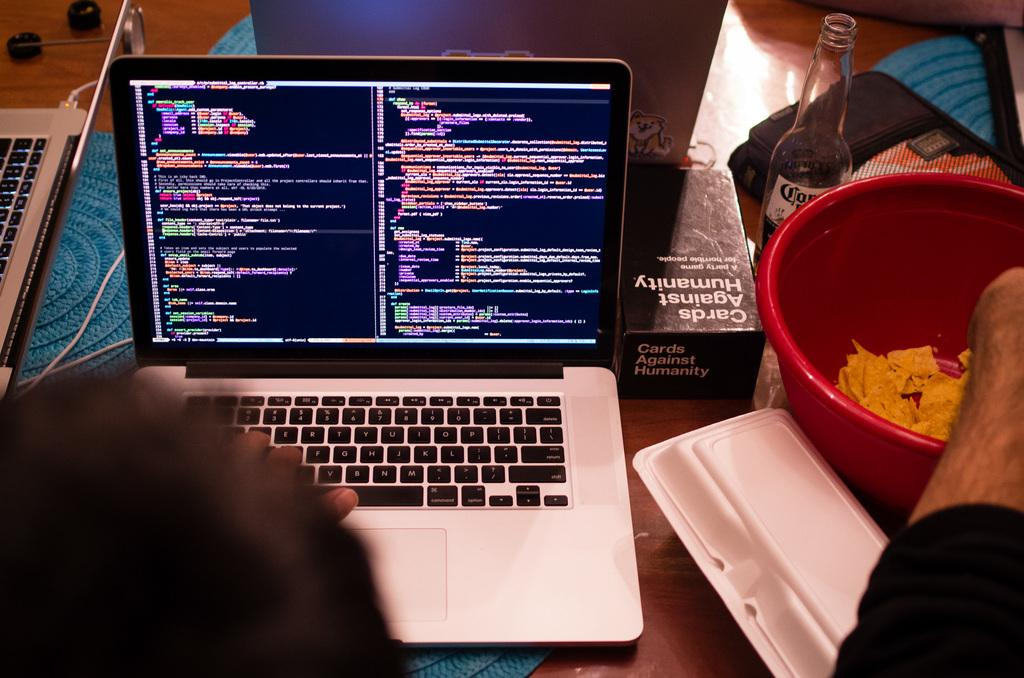What electronic device is visible in the image? There is a laptop in the image. What type of snack is in the bowl in the image? There is a bowl with chips in the image. What beverage container is present in the image? There is a cool drink bottle in the image. How many eyes can be seen on the laptop in the image? There are no eyes visible on the laptop in the image, as it is an electronic device and not a living being. 